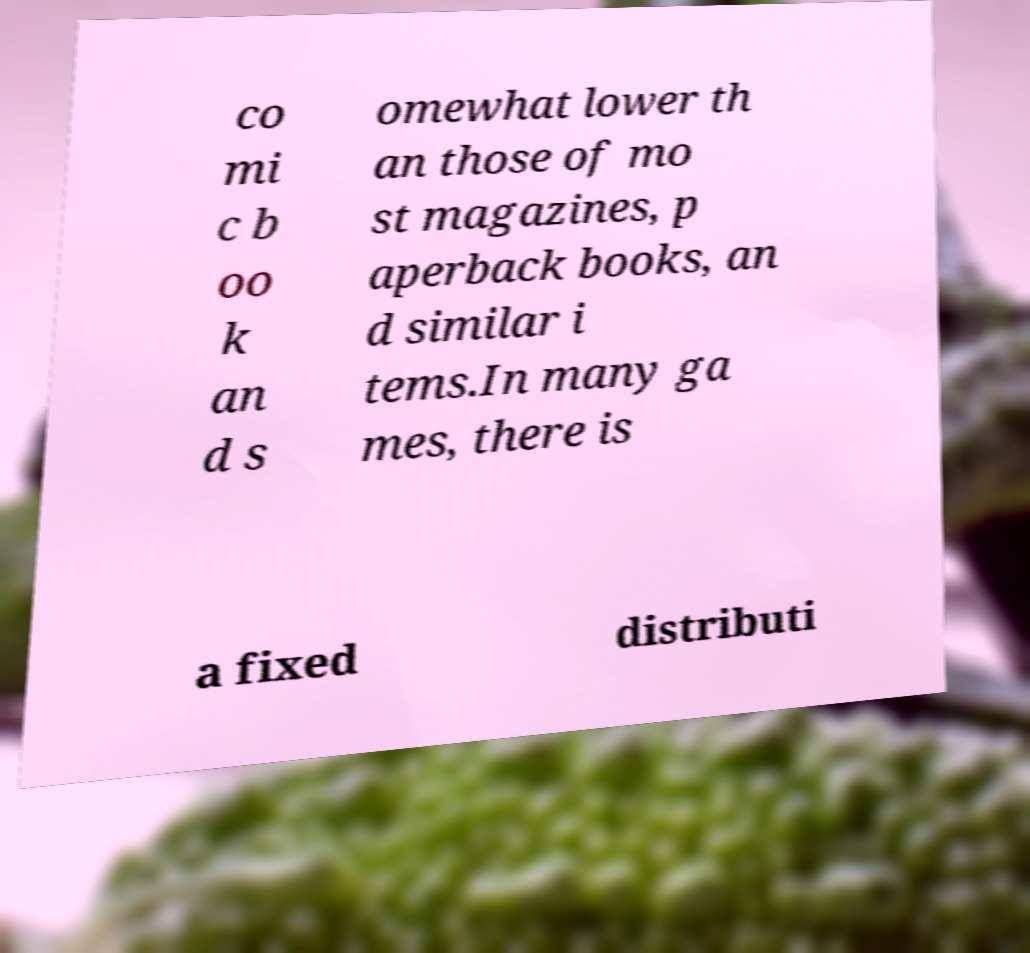Could you extract and type out the text from this image? co mi c b oo k an d s omewhat lower th an those of mo st magazines, p aperback books, an d similar i tems.In many ga mes, there is a fixed distributi 